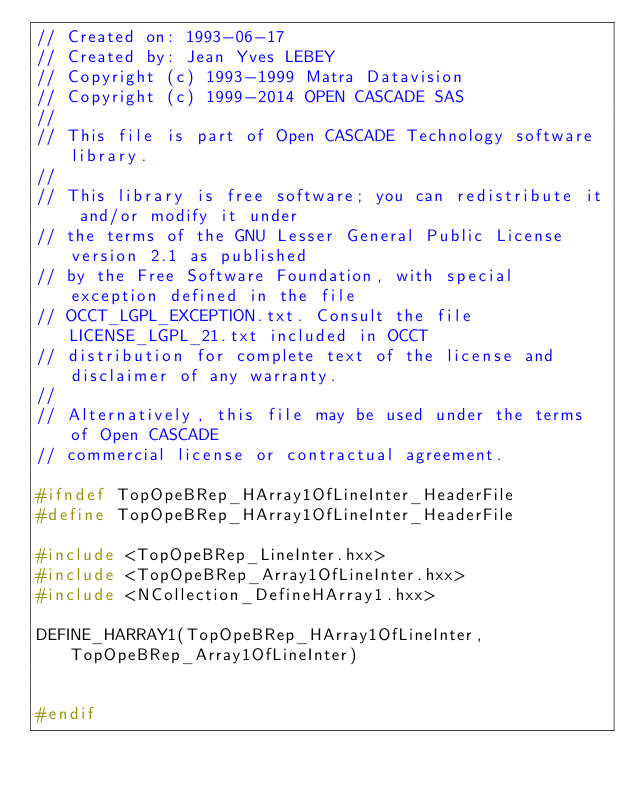<code> <loc_0><loc_0><loc_500><loc_500><_C++_>// Created on: 1993-06-17
// Created by: Jean Yves LEBEY
// Copyright (c) 1993-1999 Matra Datavision
// Copyright (c) 1999-2014 OPEN CASCADE SAS
//
// This file is part of Open CASCADE Technology software library.
//
// This library is free software; you can redistribute it and/or modify it under
// the terms of the GNU Lesser General Public License version 2.1 as published
// by the Free Software Foundation, with special exception defined in the file
// OCCT_LGPL_EXCEPTION.txt. Consult the file LICENSE_LGPL_21.txt included in OCCT
// distribution for complete text of the license and disclaimer of any warranty.
//
// Alternatively, this file may be used under the terms of Open CASCADE
// commercial license or contractual agreement.

#ifndef TopOpeBRep_HArray1OfLineInter_HeaderFile
#define TopOpeBRep_HArray1OfLineInter_HeaderFile

#include <TopOpeBRep_LineInter.hxx>
#include <TopOpeBRep_Array1OfLineInter.hxx>
#include <NCollection_DefineHArray1.hxx>

DEFINE_HARRAY1(TopOpeBRep_HArray1OfLineInter, TopOpeBRep_Array1OfLineInter)


#endif
</code> 